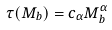<formula> <loc_0><loc_0><loc_500><loc_500>\tau ( M _ { b } ) = c _ { \alpha } M _ { b } ^ { \alpha }</formula> 